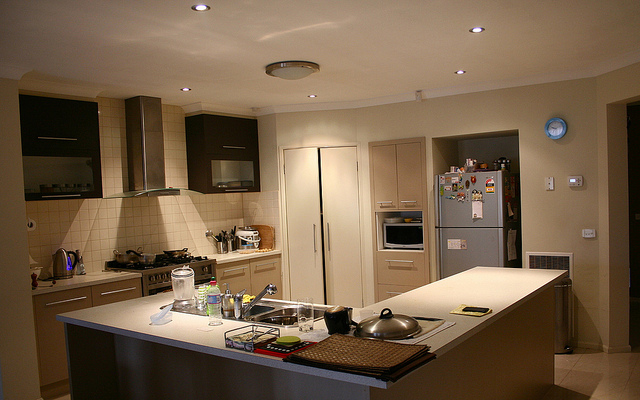<image>Is there a paper towel holder? It is uncertain whether there is a paper towel holder. Majority suggests that there is not one. Is there a paper towel holder? There is no paper towel holder in the image. 